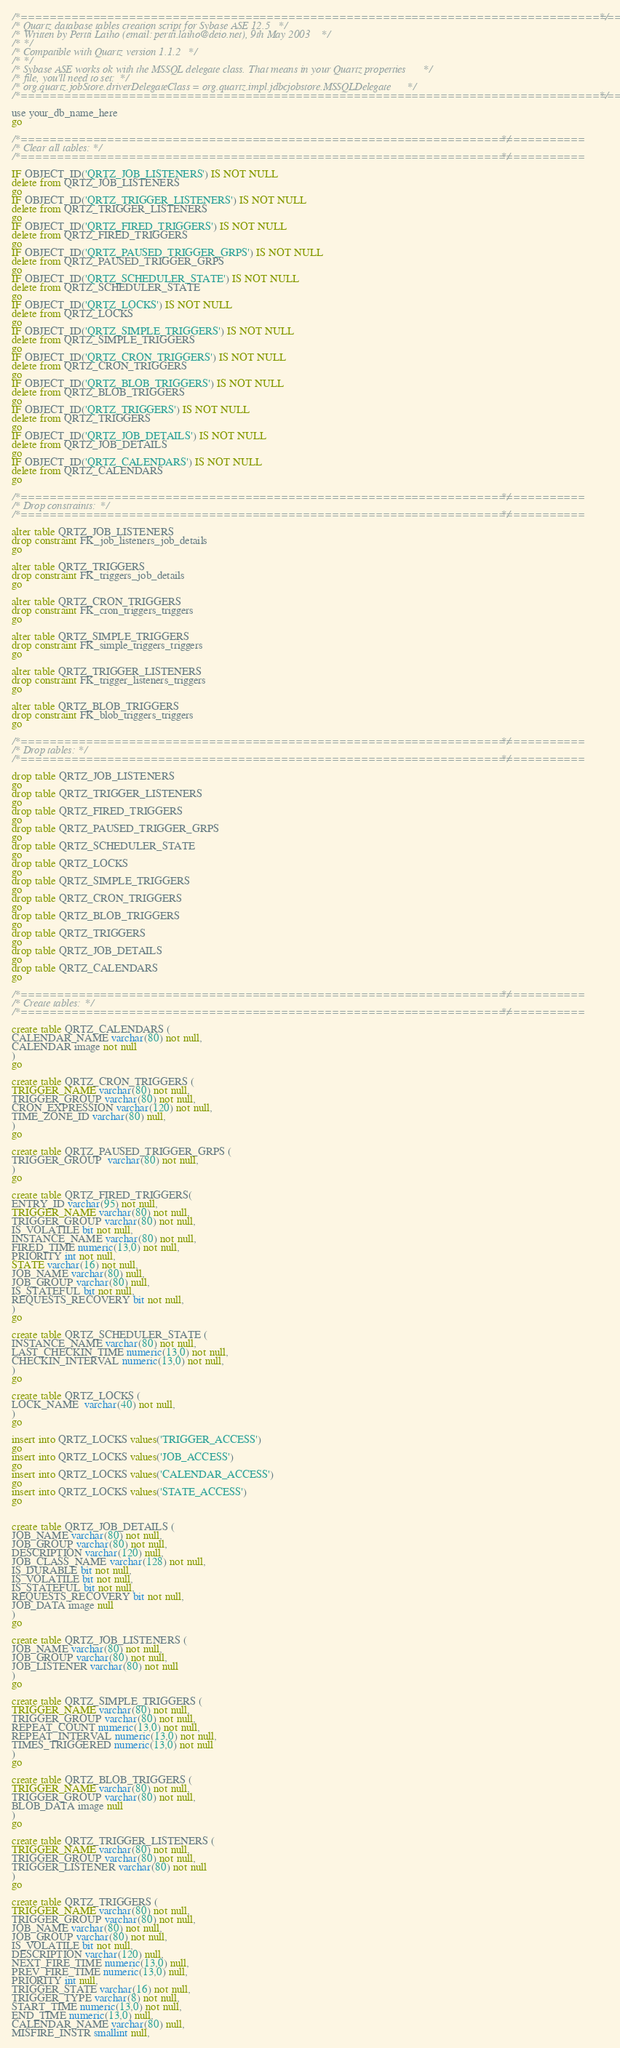<code> <loc_0><loc_0><loc_500><loc_500><_SQL_>/*==============================================================================================*/
/* Quartz database tables creation script for Sybase ASE 12.5 */
/* Written by Pertti Laiho (email: pertti.laiho@deio.net), 9th May 2003 */
/* */
/* Compatible with Quartz version 1.1.2 */
/* */
/* Sybase ASE works ok with the MSSQL delegate class. That means in your Quartz properties */
/* file, you'll need to set: */
/* org.quartz.jobStore.driverDelegateClass = org.quartz.impl.jdbcjobstore.MSSQLDelegate */
/*==============================================================================================*/

use your_db_name_here
go

/*==============================================================================*/
/* Clear all tables: */
/*==============================================================================*/

IF OBJECT_ID('QRTZ_JOB_LISTENERS') IS NOT NULL 
delete from QRTZ_JOB_LISTENERS
go
IF OBJECT_ID('QRTZ_TRIGGER_LISTENERS') IS NOT NULL 
delete from QRTZ_TRIGGER_LISTENERS
go
IF OBJECT_ID('QRTZ_FIRED_TRIGGERS') IS NOT NULL 
delete from QRTZ_FIRED_TRIGGERS
go
IF OBJECT_ID('QRTZ_PAUSED_TRIGGER_GRPS') IS NOT NULL 
delete from QRTZ_PAUSED_TRIGGER_GRPS
go
IF OBJECT_ID('QRTZ_SCHEDULER_STATE') IS NOT NULL 
delete from QRTZ_SCHEDULER_STATE
go
IF OBJECT_ID('QRTZ_LOCKS') IS NOT NULL 
delete from QRTZ_LOCKS
go
IF OBJECT_ID('QRTZ_SIMPLE_TRIGGERS') IS NOT NULL 
delete from QRTZ_SIMPLE_TRIGGERS
go
IF OBJECT_ID('QRTZ_CRON_TRIGGERS') IS NOT NULL 
delete from QRTZ_CRON_TRIGGERS
go
IF OBJECT_ID('QRTZ_BLOB_TRIGGERS') IS NOT NULL 
delete from QRTZ_BLOB_TRIGGERS
go
IF OBJECT_ID('QRTZ_TRIGGERS') IS NOT NULL 
delete from QRTZ_TRIGGERS
go
IF OBJECT_ID('QRTZ_JOB_DETAILS') IS NOT NULL 
delete from QRTZ_JOB_DETAILS
go
IF OBJECT_ID('QRTZ_CALENDARS') IS NOT NULL 
delete from QRTZ_CALENDARS
go

/*==============================================================================*/
/* Drop constraints: */
/*==============================================================================*/

alter table QRTZ_JOB_LISTENERS
drop constraint FK_job_listeners_job_details
go

alter table QRTZ_TRIGGERS
drop constraint FK_triggers_job_details
go

alter table QRTZ_CRON_TRIGGERS
drop constraint FK_cron_triggers_triggers
go

alter table QRTZ_SIMPLE_TRIGGERS
drop constraint FK_simple_triggers_triggers
go

alter table QRTZ_TRIGGER_LISTENERS
drop constraint FK_trigger_listeners_triggers
go

alter table QRTZ_BLOB_TRIGGERS
drop constraint FK_blob_triggers_triggers
go

/*==============================================================================*/
/* Drop tables: */
/*==============================================================================*/

drop table QRTZ_JOB_LISTENERS
go
drop table QRTZ_TRIGGER_LISTENERS
go
drop table QRTZ_FIRED_TRIGGERS
go
drop table QRTZ_PAUSED_TRIGGER_GRPS
go
drop table QRTZ_SCHEDULER_STATE
go
drop table QRTZ_LOCKS
go
drop table QRTZ_SIMPLE_TRIGGERS
go
drop table QRTZ_CRON_TRIGGERS
go
drop table QRTZ_BLOB_TRIGGERS
go
drop table QRTZ_TRIGGERS
go
drop table QRTZ_JOB_DETAILS
go
drop table QRTZ_CALENDARS
go

/*==============================================================================*/
/* Create tables: */
/*==============================================================================*/

create table QRTZ_CALENDARS (
CALENDAR_NAME varchar(80) not null,
CALENDAR image not null
)
go

create table QRTZ_CRON_TRIGGERS (
TRIGGER_NAME varchar(80) not null,
TRIGGER_GROUP varchar(80) not null,
CRON_EXPRESSION varchar(120) not null,
TIME_ZONE_ID varchar(80) null,
)
go

create table QRTZ_PAUSED_TRIGGER_GRPS (
TRIGGER_GROUP  varchar(80) not null, 
)
go

create table QRTZ_FIRED_TRIGGERS(
ENTRY_ID varchar(95) not null,
TRIGGER_NAME varchar(80) not null,
TRIGGER_GROUP varchar(80) not null,
IS_VOLATILE bit not null,
INSTANCE_NAME varchar(80) not null,
FIRED_TIME numeric(13,0) not null,
PRIORITY int not null,
STATE varchar(16) not null,
JOB_NAME varchar(80) null,
JOB_GROUP varchar(80) null,
IS_STATEFUL bit not null,
REQUESTS_RECOVERY bit not null,
)
go

create table QRTZ_SCHEDULER_STATE (
INSTANCE_NAME varchar(80) not null,
LAST_CHECKIN_TIME numeric(13,0) not null,
CHECKIN_INTERVAL numeric(13,0) not null,
)
go

create table QRTZ_LOCKS (
LOCK_NAME  varchar(40) not null, 
)
go

insert into QRTZ_LOCKS values('TRIGGER_ACCESS')
go
insert into QRTZ_LOCKS values('JOB_ACCESS')
go
insert into QRTZ_LOCKS values('CALENDAR_ACCESS')
go
insert into QRTZ_LOCKS values('STATE_ACCESS')
go


create table QRTZ_JOB_DETAILS (
JOB_NAME varchar(80) not null,
JOB_GROUP varchar(80) not null,
DESCRIPTION varchar(120) null,
JOB_CLASS_NAME varchar(128) not null,
IS_DURABLE bit not null,
IS_VOLATILE bit not null,
IS_STATEFUL bit not null,
REQUESTS_RECOVERY bit not null,
JOB_DATA image null
)
go

create table QRTZ_JOB_LISTENERS (
JOB_NAME varchar(80) not null,
JOB_GROUP varchar(80) not null,
JOB_LISTENER varchar(80) not null
)
go

create table QRTZ_SIMPLE_TRIGGERS (
TRIGGER_NAME varchar(80) not null,
TRIGGER_GROUP varchar(80) not null,
REPEAT_COUNT numeric(13,0) not null,
REPEAT_INTERVAL numeric(13,0) not null,
TIMES_TRIGGERED numeric(13,0) not null
)
go

create table QRTZ_BLOB_TRIGGERS (
TRIGGER_NAME varchar(80) not null,
TRIGGER_GROUP varchar(80) not null,
BLOB_DATA image null
)
go

create table QRTZ_TRIGGER_LISTENERS (
TRIGGER_NAME varchar(80) not null,
TRIGGER_GROUP varchar(80) not null,
TRIGGER_LISTENER varchar(80) not null
)
go

create table QRTZ_TRIGGERS (
TRIGGER_NAME varchar(80) not null,
TRIGGER_GROUP varchar(80) not null,
JOB_NAME varchar(80) not null,
JOB_GROUP varchar(80) not null,
IS_VOLATILE bit not null,
DESCRIPTION varchar(120) null,
NEXT_FIRE_TIME numeric(13,0) null,
PREV_FIRE_TIME numeric(13,0) null,
PRIORITY int null,
TRIGGER_STATE varchar(16) not null,
TRIGGER_TYPE varchar(8) not null,
START_TIME numeric(13,0) not null,
END_TIME numeric(13,0) null,
CALENDAR_NAME varchar(80) null,
MISFIRE_INSTR smallint null,</code> 